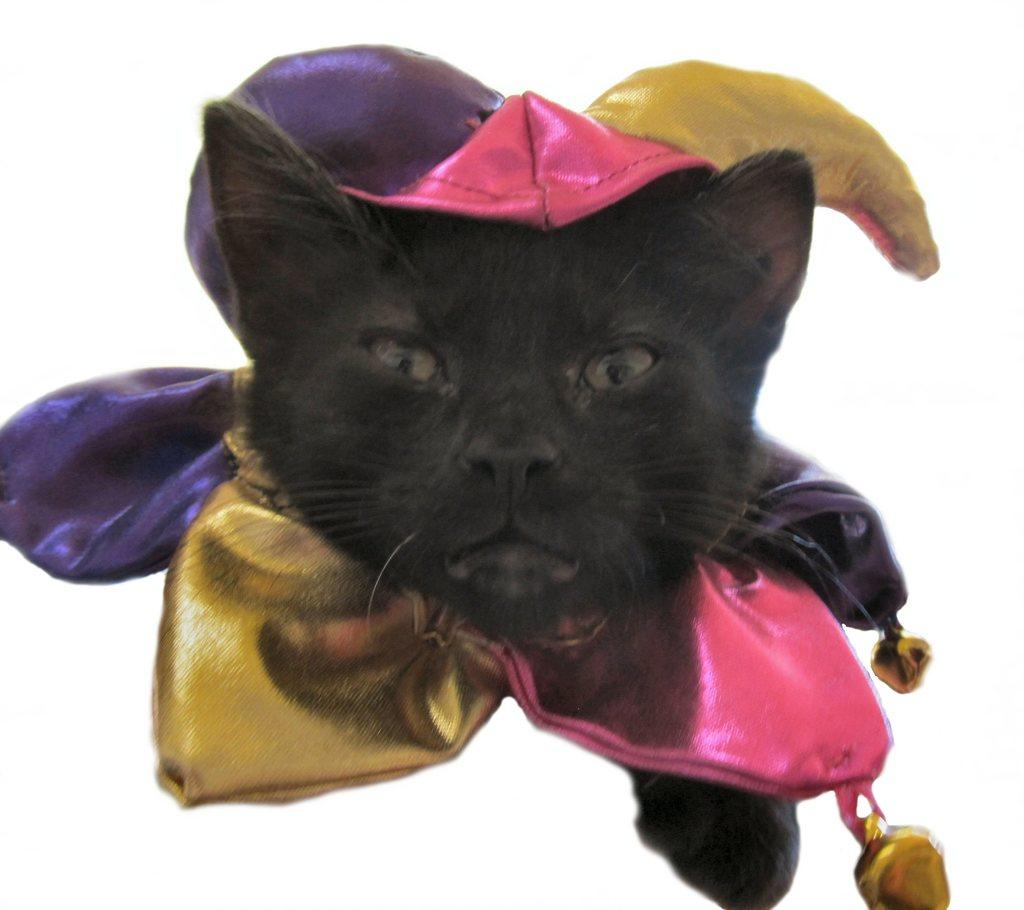What type of animal is in the image? There is a cat in the image. What color is the cat? The cat is black in color. What is the cat wearing? The cat is wearing pink, violet, and gold-colored clothes. What is the color of the background in the image? The background of the image is white. What type of linen is visible in the image? There is no linen present in the image. How many ants can be seen crawling on the cat in the image? There are no ants visible in the image; the cat is wearing clothes and is not interacting with any insects. 